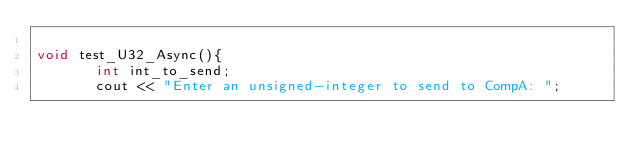Convert code to text. <code><loc_0><loc_0><loc_500><loc_500><_C++_>
void test_U32_Async(){
       int int_to_send;
       cout << "Enter an unsigned-integer to send to CompA: ";</code> 